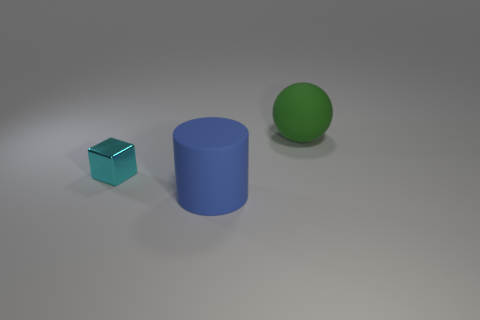Add 1 cyan cubes. How many objects exist? 4 Subtract all big green matte spheres. Subtract all big cylinders. How many objects are left? 1 Add 1 green things. How many green things are left? 2 Add 3 small yellow rubber cylinders. How many small yellow rubber cylinders exist? 3 Subtract 0 brown spheres. How many objects are left? 3 Subtract all spheres. How many objects are left? 2 